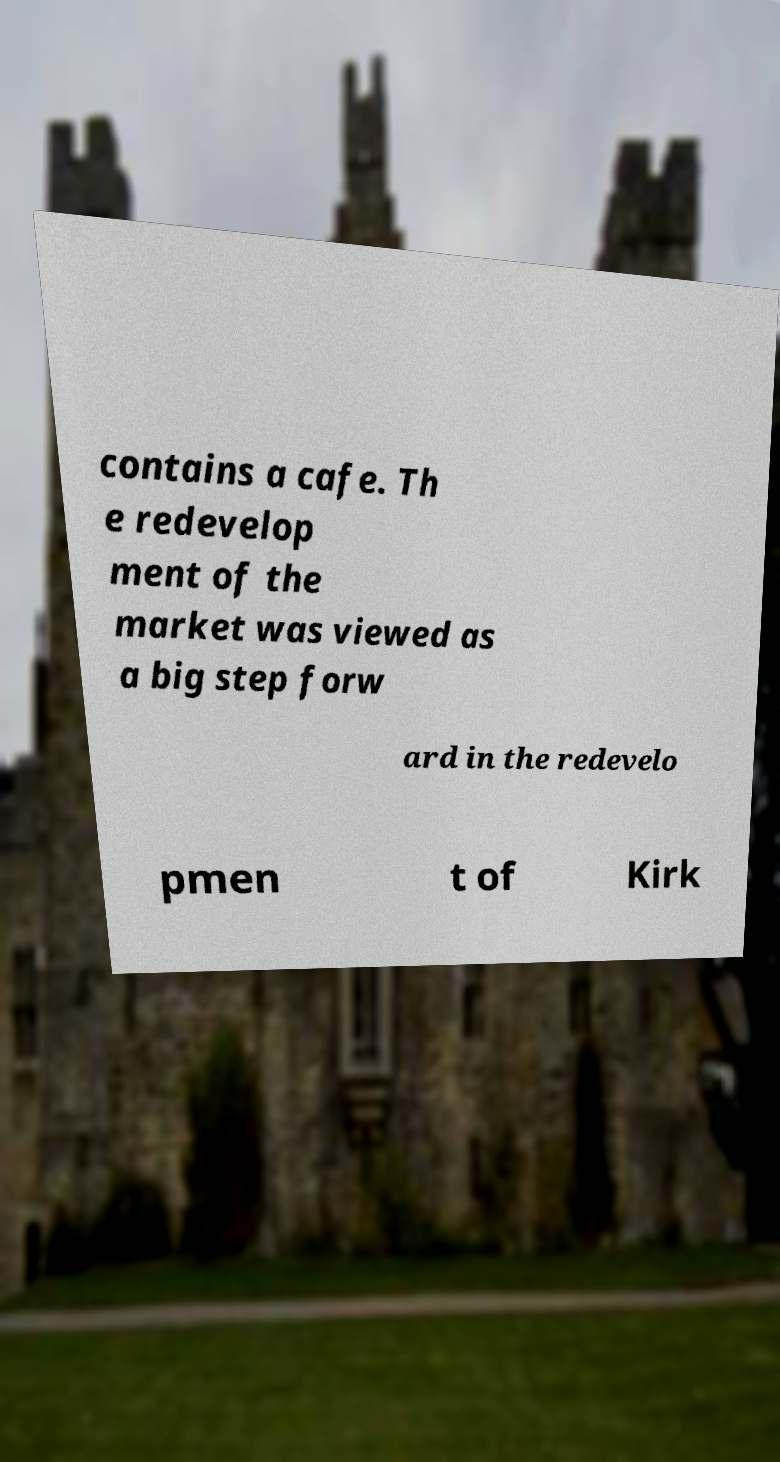Could you extract and type out the text from this image? contains a cafe. Th e redevelop ment of the market was viewed as a big step forw ard in the redevelo pmen t of Kirk 